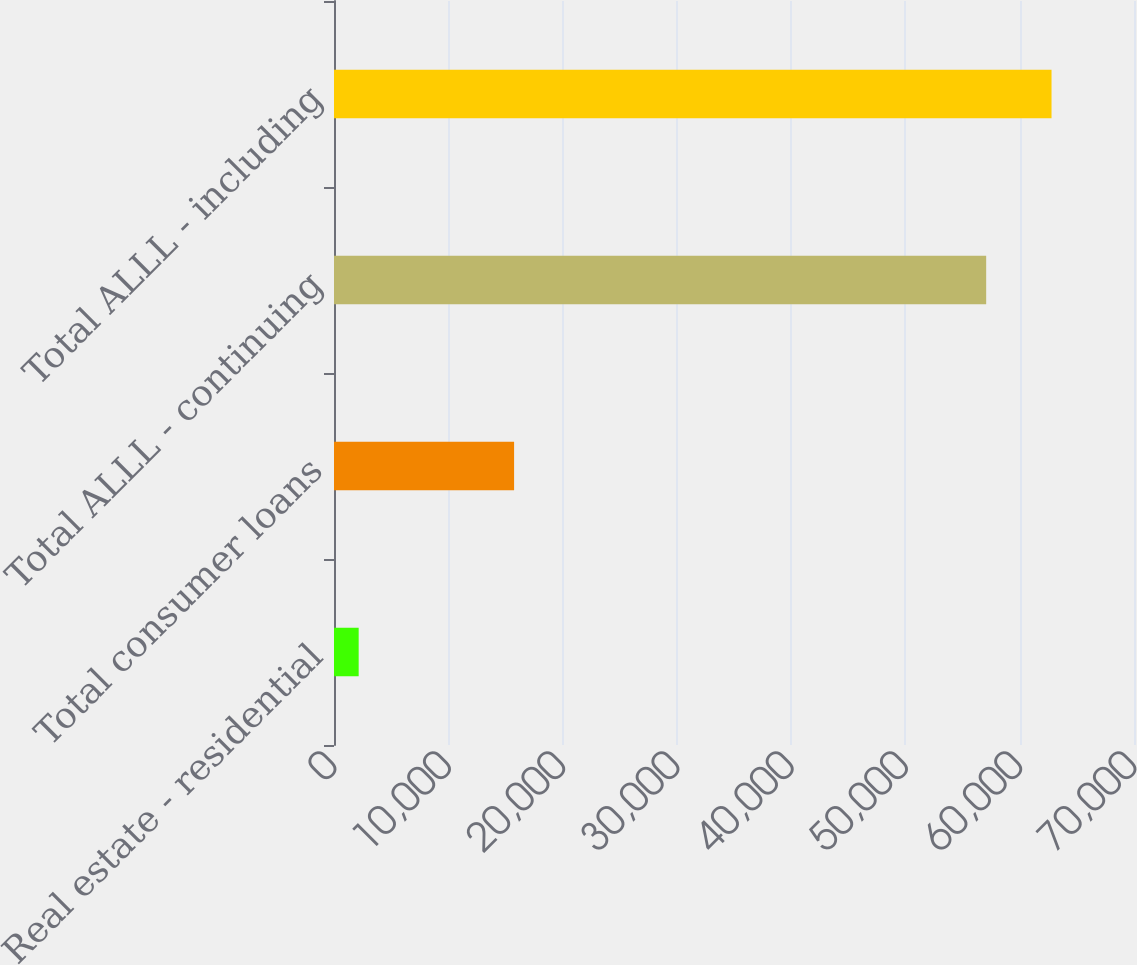Convert chart. <chart><loc_0><loc_0><loc_500><loc_500><bar_chart><fcel>Real estate - residential<fcel>Total consumer loans<fcel>Total ALLL - continuing<fcel>Total ALLL - including<nl><fcel>2159<fcel>15758<fcel>57066<fcel>62784.5<nl></chart> 